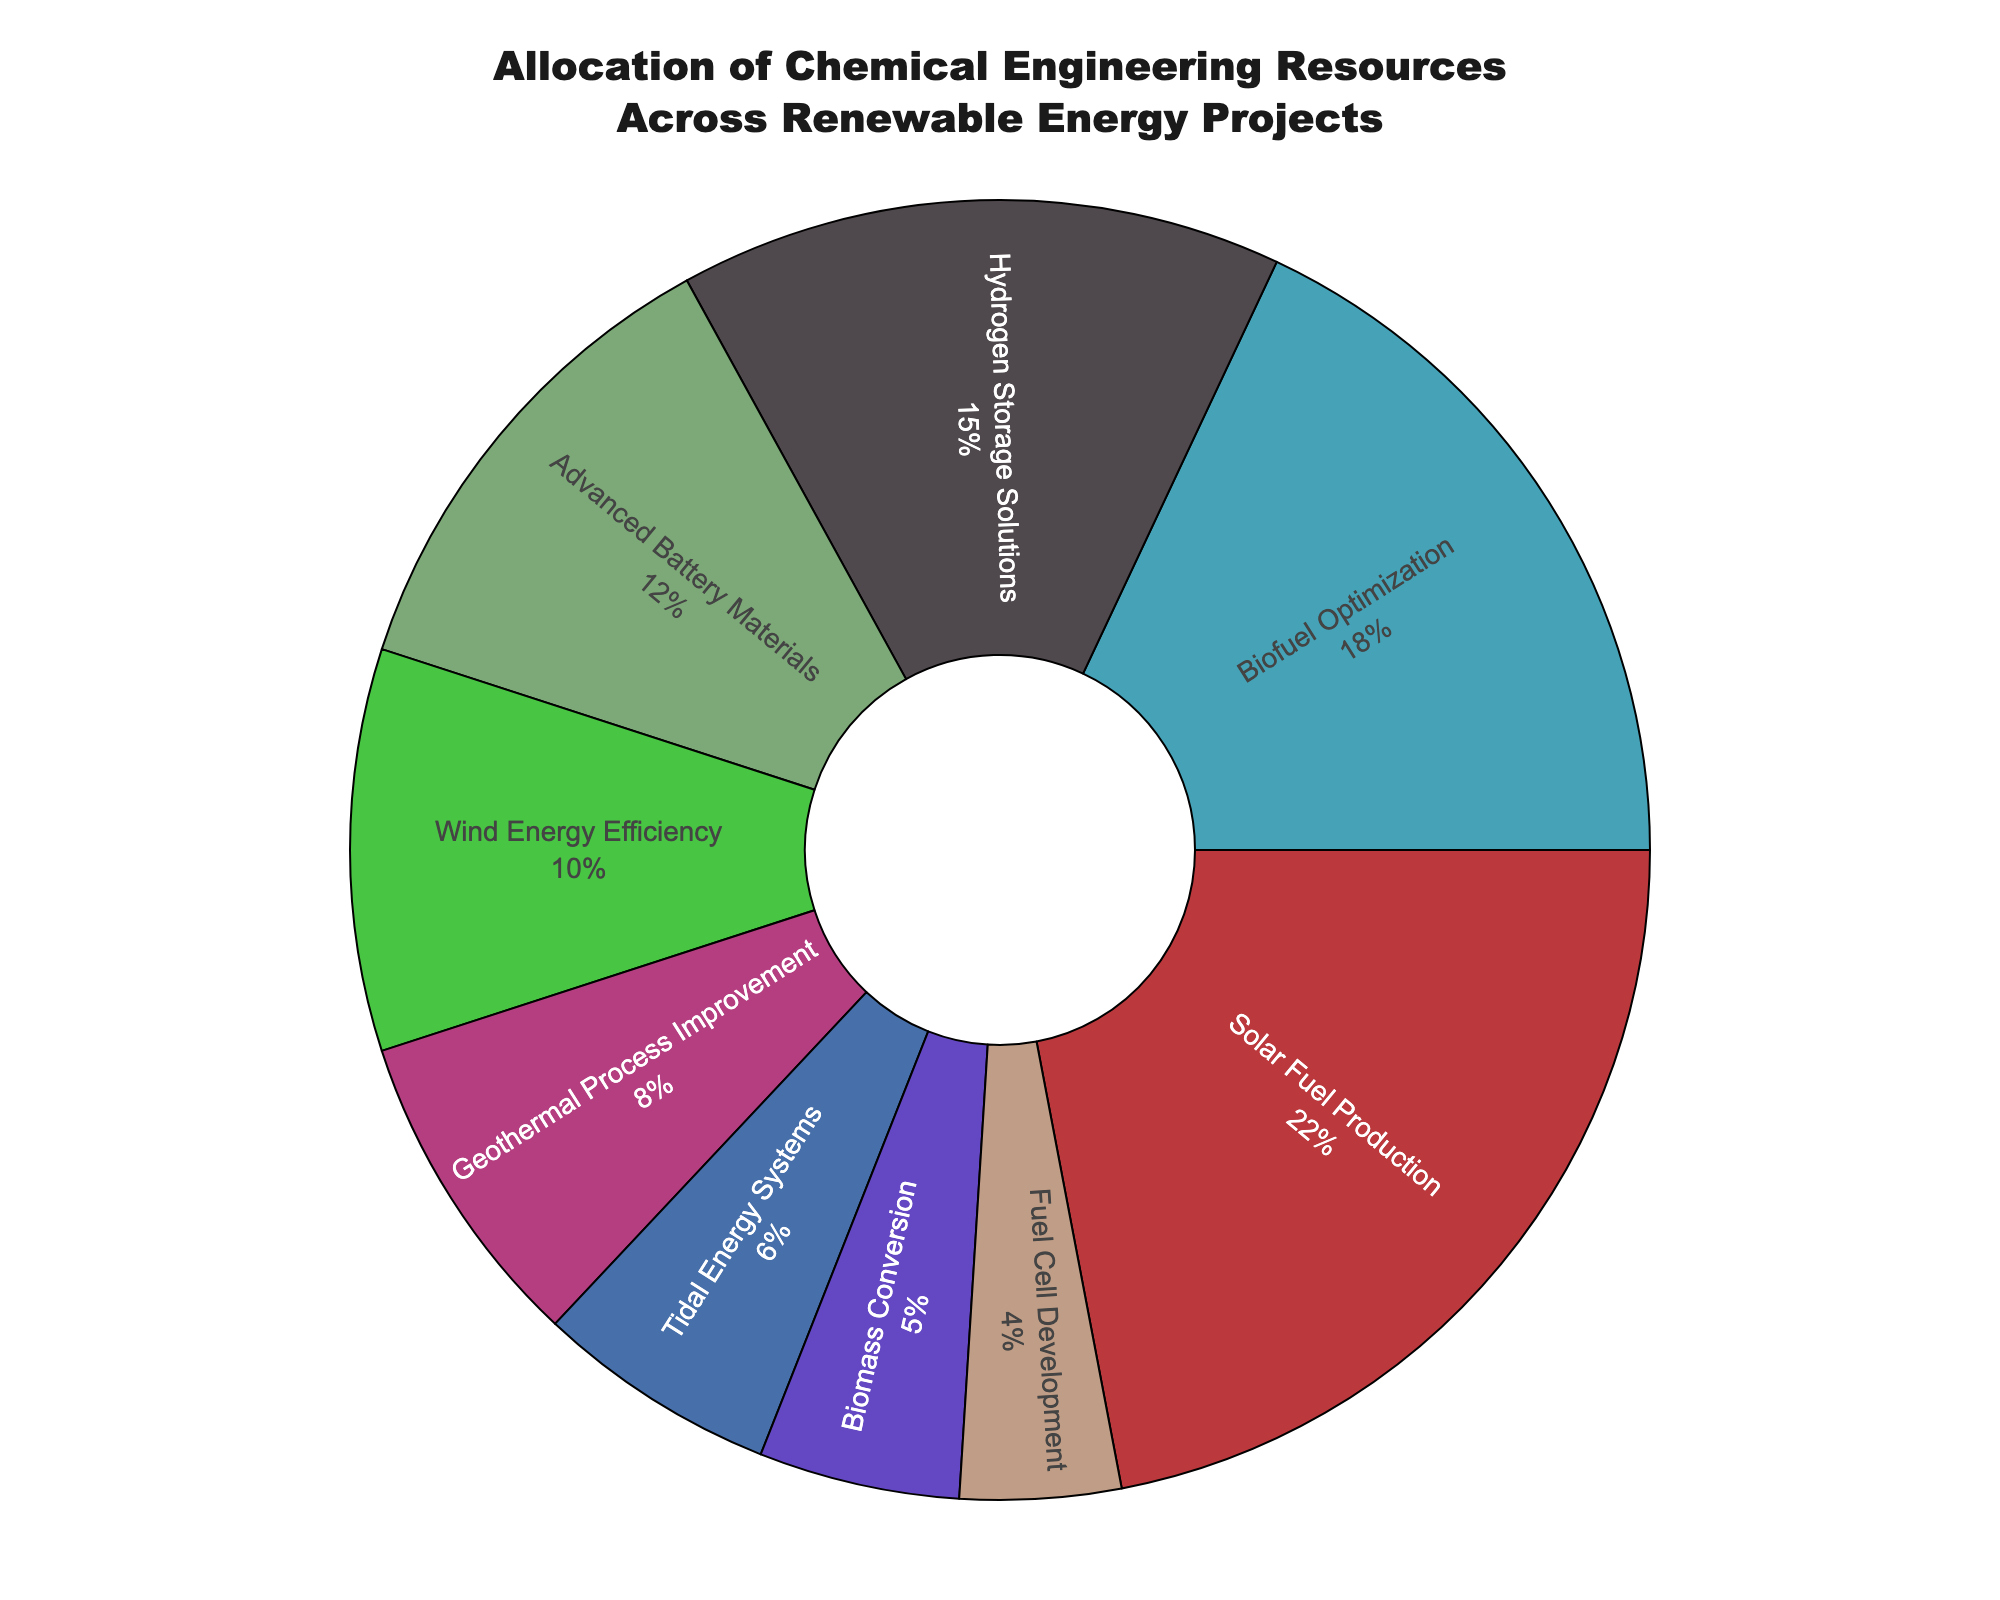Which project receives the highest allocation of chemical engineering resources? The chart visually shows that the largest segment corresponds to the "Solar Fuel Production" project. This indicates it has the highest percentage.
Answer: Solar Fuel Production How much more does "Solar Fuel Production" receive in comparison to "Biofuel Optimization"? "Solar Fuel Production" receives 22% while "Biofuel Optimization" receives 18%. The difference is calculated as 22% - 18% = 4%.
Answer: 4% What is the total percentage allocated to Hydro-based projects ("Hydrogen Storage Solutions," "Tidal Energy Systems," "Fuel Cell Development")? Add the percentages of "Hydrogen Storage Solutions" (15%), "Tidal Energy Systems" (6%), and "Fuel Cell Development" (4%). 15% + 6% + 4% = 25%.
Answer: 25% How do the allocations for "Advanced Battery Materials" and "Wind Energy Efficiency" compare? "Advanced Battery Materials" has an allocation of 12% and "Wind Energy Efficiency" has an allocation of 10%. "Advanced Battery Materials" receives more resources than "Wind Energy Efficiency."
Answer: Advanced Battery Materials Which projects combined account for less than 10% of the allocation? Examine the chart and identify the segments with percentages less than 10%. "Biomass Conversion" (5%) and "Fuel Cell Development" (4%) are less than 10%. Their combined percentage is 5% + 4% = 9%, which is less than 10%.
Answer: Biomass Conversion and Fuel Cell Development Is the allocation to "Geothermal Process Improvement" greater or less than the combined allocation for "Tidal Energy Systems" and "Biomass Conversion"? "Geothermal Process Improvement" has 8%. "Tidal Energy Systems" is 6% and "Biomass Conversion" is 5%. Combined, "Tidal Energy Systems" and "Biomass Conversion" account for 6% + 5% = 11%, which is greater than 8%.
Answer: Less What is the proportion of resources allocated to the top three projects combined? The top three projects by allocation are "Solar Fuel Production" (22%), "Biofuel Optimization" (18%), and "Hydrogen Storage Solutions" (15%). Adding these gives 22% + 18% + 15% = 55%.
Answer: 55% Which project has the smallest allocation, and what percentage does it receive? The chart shows the smallest segment, which corresponds to the "Fuel Cell Development" project. This indicates it receives the least resources at 4%.
Answer: Fuel Cell Development What is the visual indication that "Biofuel Optimization" has a significant allocation? "Biofuel Optimization" has a large segment, colored distinctly, making it prominent and close to the size of the largest segment, indicating its significant allocation.
Answer: Large segment, distinct color 